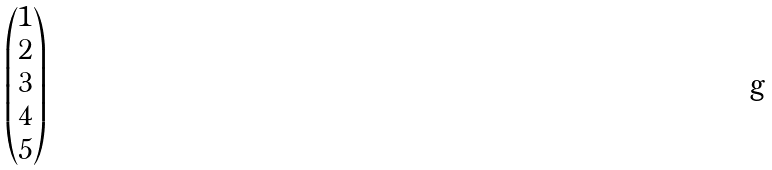Convert formula to latex. <formula><loc_0><loc_0><loc_500><loc_500>\begin{pmatrix} 1 \\ 2 \\ 3 \\ 4 \\ 5 \end{pmatrix}</formula> 